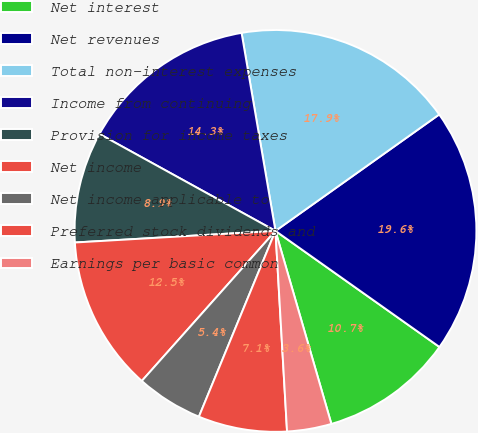<chart> <loc_0><loc_0><loc_500><loc_500><pie_chart><fcel>Net interest<fcel>Net revenues<fcel>Total non-interest expenses<fcel>Income from continuing<fcel>Provision for income taxes<fcel>Net income<fcel>Net income applicable to<fcel>Preferred stock dividends and<fcel>Earnings per basic common<nl><fcel>10.71%<fcel>19.64%<fcel>17.86%<fcel>14.29%<fcel>8.93%<fcel>12.5%<fcel>5.36%<fcel>7.14%<fcel>3.57%<nl></chart> 